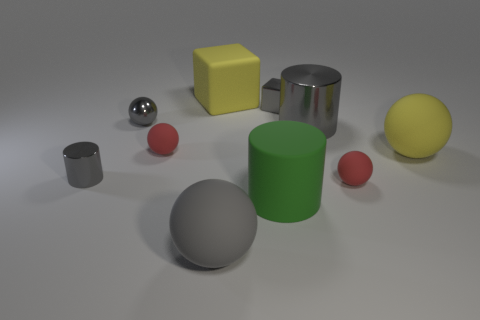How many things are either gray cylinders that are to the left of the large gray ball or big cyan shiny cubes?
Offer a terse response. 1. Are there fewer large rubber cylinders right of the shiny block than large rubber things that are to the right of the large gray matte object?
Make the answer very short. Yes. There is a green object; are there any gray metallic balls on the left side of it?
Give a very brief answer. Yes. What number of things are either large objects that are right of the large yellow rubber cube or small metal objects in front of the small gray sphere?
Your answer should be compact. 4. What number of tiny cylinders are the same color as the large rubber cylinder?
Keep it short and to the point. 0. There is a large rubber object that is the same shape as the big gray shiny thing; what color is it?
Ensure brevity in your answer.  Green. There is a rubber thing that is both in front of the tiny metal cylinder and behind the green object; what is its shape?
Provide a succinct answer. Sphere. Is the number of small purple balls greater than the number of blocks?
Provide a short and direct response. No. What material is the tiny gray block?
Offer a very short reply. Metal. Is there any other thing that has the same size as the yellow sphere?
Keep it short and to the point. Yes. 